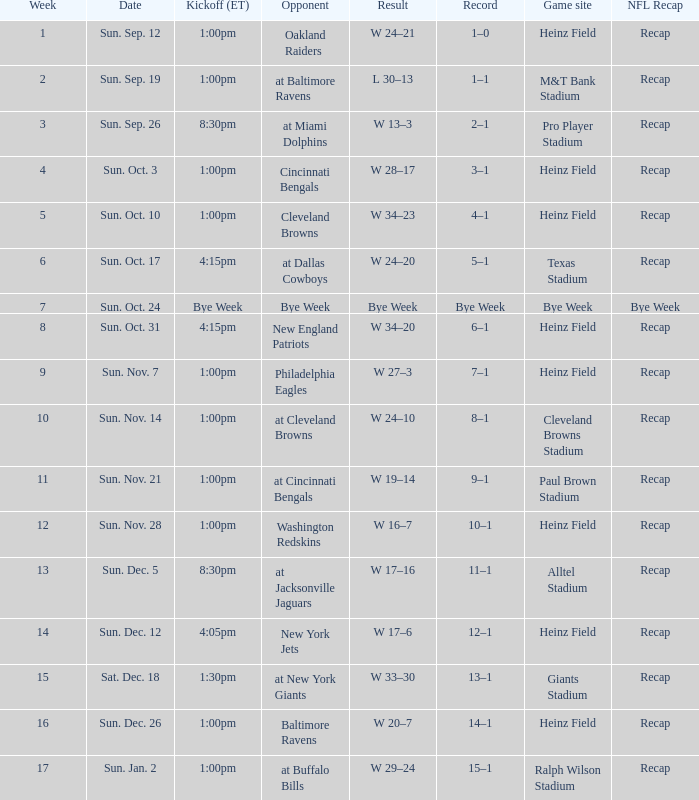Which rival has a playing site at heinz field and a record of three wins and one loss? Cincinnati Bengals. 